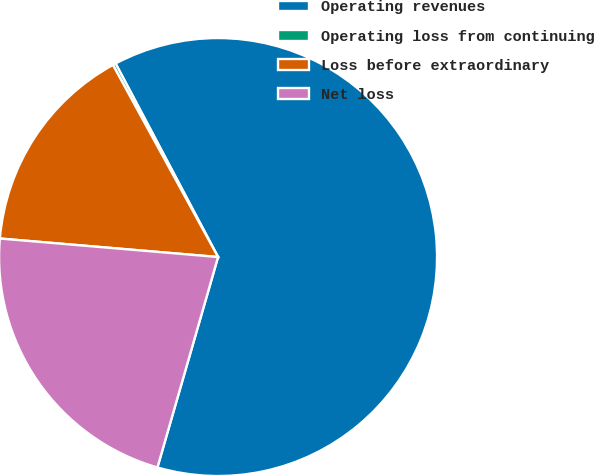<chart> <loc_0><loc_0><loc_500><loc_500><pie_chart><fcel>Operating revenues<fcel>Operating loss from continuing<fcel>Loss before extraordinary<fcel>Net loss<nl><fcel>62.21%<fcel>0.22%<fcel>15.68%<fcel>21.88%<nl></chart> 